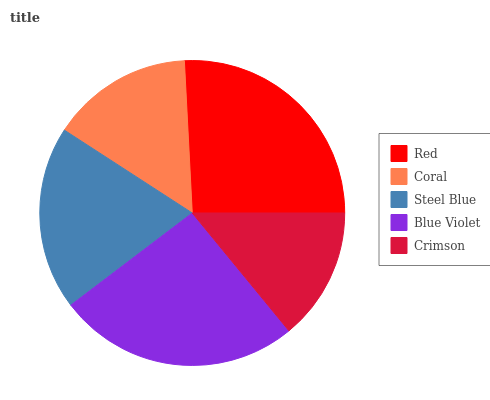Is Crimson the minimum?
Answer yes or no. Yes. Is Red the maximum?
Answer yes or no. Yes. Is Coral the minimum?
Answer yes or no. No. Is Coral the maximum?
Answer yes or no. No. Is Red greater than Coral?
Answer yes or no. Yes. Is Coral less than Red?
Answer yes or no. Yes. Is Coral greater than Red?
Answer yes or no. No. Is Red less than Coral?
Answer yes or no. No. Is Steel Blue the high median?
Answer yes or no. Yes. Is Steel Blue the low median?
Answer yes or no. Yes. Is Red the high median?
Answer yes or no. No. Is Blue Violet the low median?
Answer yes or no. No. 